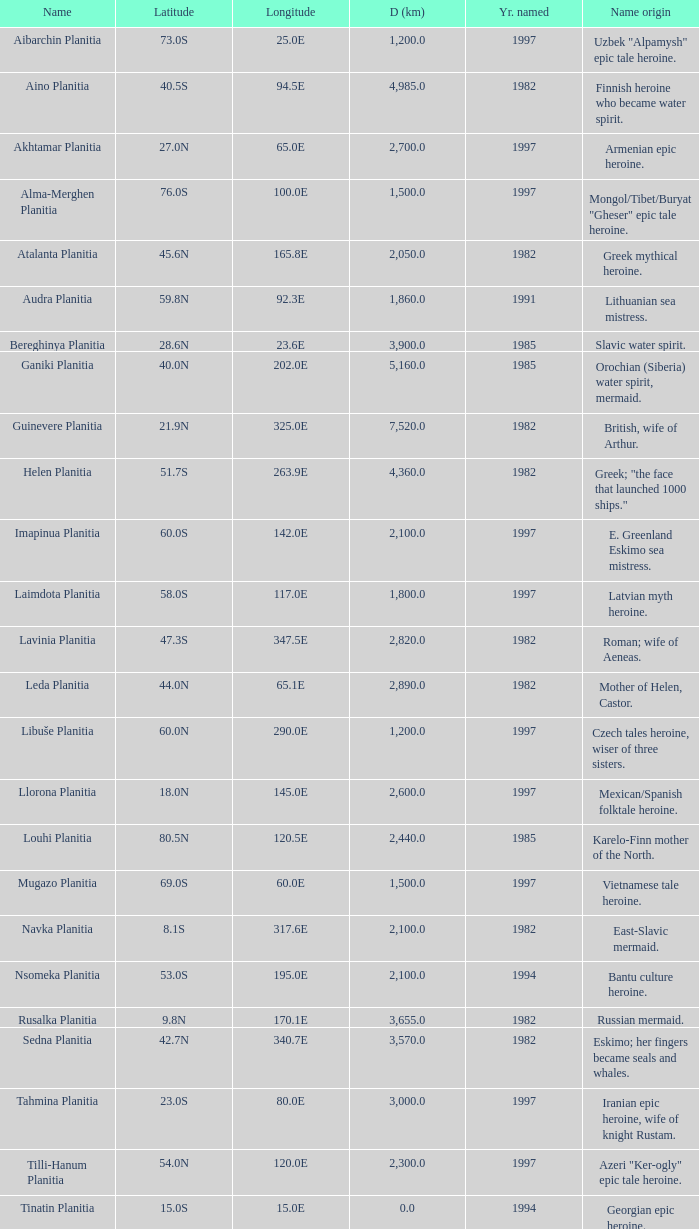Could you help me parse every detail presented in this table? {'header': ['Name', 'Latitude', 'Longitude', 'D (km)', 'Yr. named', 'Name origin'], 'rows': [['Aibarchin Planitia', '73.0S', '25.0E', '1,200.0', '1997', 'Uzbek "Alpamysh" epic tale heroine.'], ['Aino Planitia', '40.5S', '94.5E', '4,985.0', '1982', 'Finnish heroine who became water spirit.'], ['Akhtamar Planitia', '27.0N', '65.0E', '2,700.0', '1997', 'Armenian epic heroine.'], ['Alma-Merghen Planitia', '76.0S', '100.0E', '1,500.0', '1997', 'Mongol/Tibet/Buryat "Gheser" epic tale heroine.'], ['Atalanta Planitia', '45.6N', '165.8E', '2,050.0', '1982', 'Greek mythical heroine.'], ['Audra Planitia', '59.8N', '92.3E', '1,860.0', '1991', 'Lithuanian sea mistress.'], ['Bereghinya Planitia', '28.6N', '23.6E', '3,900.0', '1985', 'Slavic water spirit.'], ['Ganiki Planitia', '40.0N', '202.0E', '5,160.0', '1985', 'Orochian (Siberia) water spirit, mermaid.'], ['Guinevere Planitia', '21.9N', '325.0E', '7,520.0', '1982', 'British, wife of Arthur.'], ['Helen Planitia', '51.7S', '263.9E', '4,360.0', '1982', 'Greek; "the face that launched 1000 ships."'], ['Imapinua Planitia', '60.0S', '142.0E', '2,100.0', '1997', 'E. Greenland Eskimo sea mistress.'], ['Laimdota Planitia', '58.0S', '117.0E', '1,800.0', '1997', 'Latvian myth heroine.'], ['Lavinia Planitia', '47.3S', '347.5E', '2,820.0', '1982', 'Roman; wife of Aeneas.'], ['Leda Planitia', '44.0N', '65.1E', '2,890.0', '1982', 'Mother of Helen, Castor.'], ['Libuše Planitia', '60.0N', '290.0E', '1,200.0', '1997', 'Czech tales heroine, wiser of three sisters.'], ['Llorona Planitia', '18.0N', '145.0E', '2,600.0', '1997', 'Mexican/Spanish folktale heroine.'], ['Louhi Planitia', '80.5N', '120.5E', '2,440.0', '1985', 'Karelo-Finn mother of the North.'], ['Mugazo Planitia', '69.0S', '60.0E', '1,500.0', '1997', 'Vietnamese tale heroine.'], ['Navka Planitia', '8.1S', '317.6E', '2,100.0', '1982', 'East-Slavic mermaid.'], ['Nsomeka Planitia', '53.0S', '195.0E', '2,100.0', '1994', 'Bantu culture heroine.'], ['Rusalka Planitia', '9.8N', '170.1E', '3,655.0', '1982', 'Russian mermaid.'], ['Sedna Planitia', '42.7N', '340.7E', '3,570.0', '1982', 'Eskimo; her fingers became seals and whales.'], ['Tahmina Planitia', '23.0S', '80.0E', '3,000.0', '1997', 'Iranian epic heroine, wife of knight Rustam.'], ['Tilli-Hanum Planitia', '54.0N', '120.0E', '2,300.0', '1997', 'Azeri "Ker-ogly" epic tale heroine.'], ['Tinatin Planitia', '15.0S', '15.0E', '0.0', '1994', 'Georgian epic heroine.'], ['Undine Planitia', '13.0N', '303.0E', '2,800.0', '1997', 'Lithuanian water nymph, mermaid.'], ['Vellamo Planitia', '45.4N', '149.1E', '2,155.0', '1985', 'Karelo-Finn mermaid.']]} What is the diameter (km) of longitude 170.1e 3655.0. 